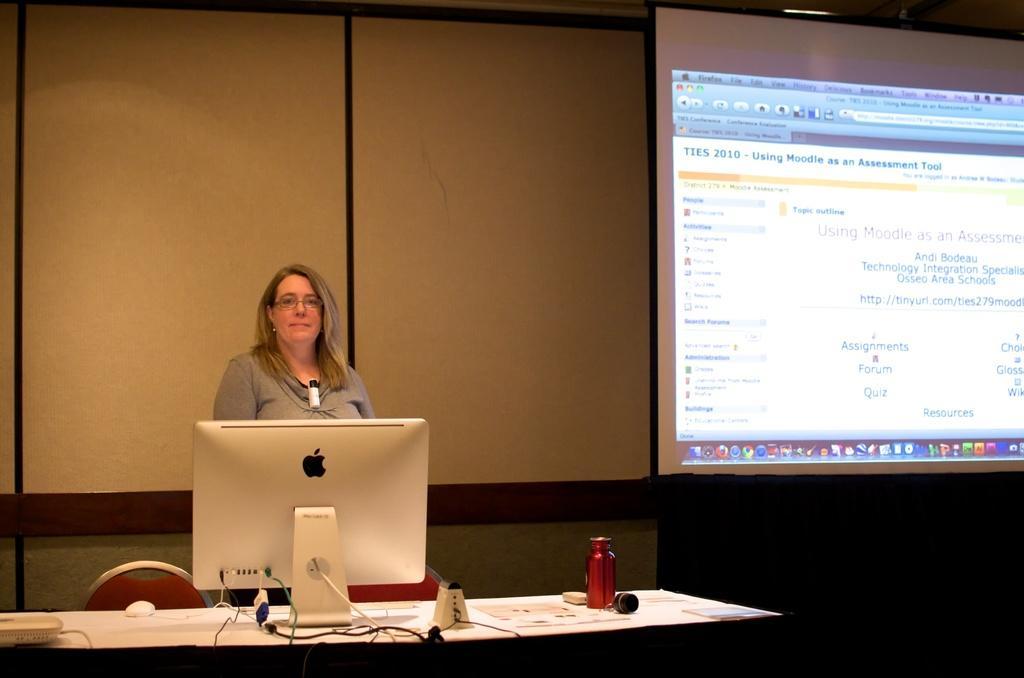Describe this image in one or two sentences. In this picture we can see a woman, she wore spectacles, in front of her we can see a monitor, mouse, bottle and other things on the table, beside to her we can see a projector screen. 